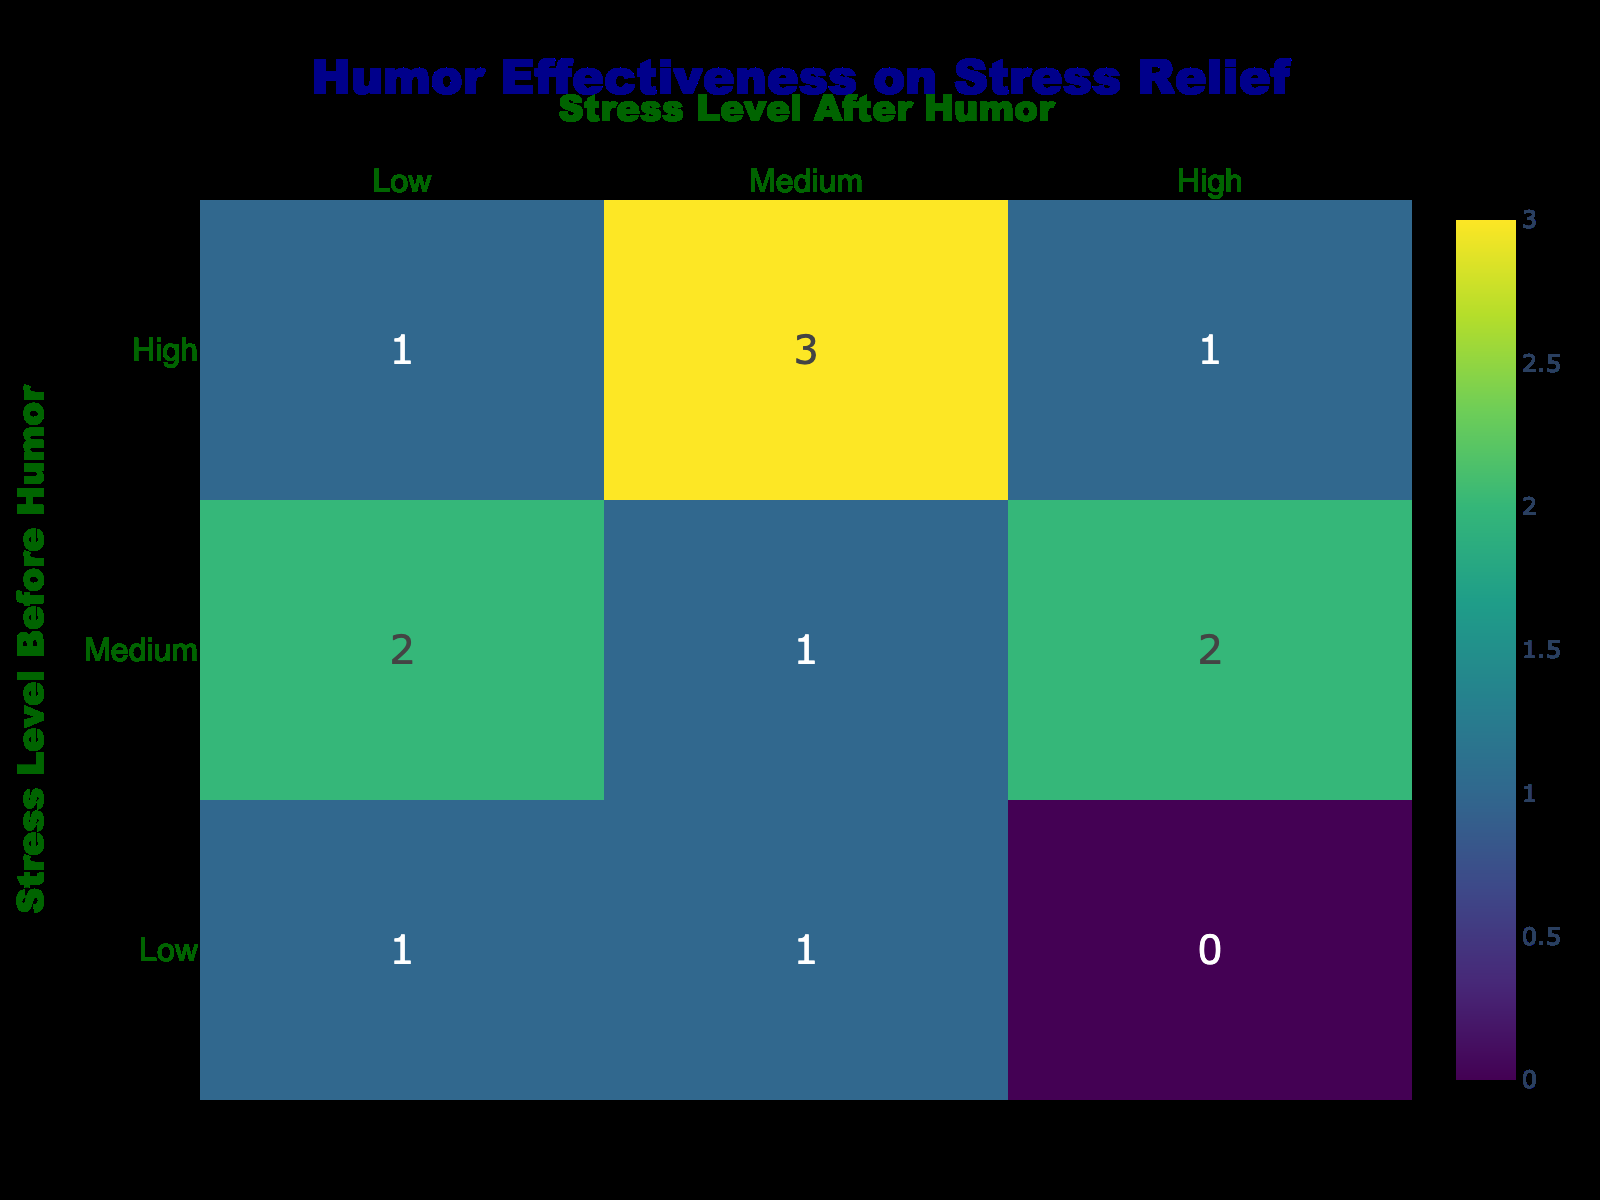What is the stress level after humor for the age group 18-24 with a high stress level before humor? Referring to the table, the only entry for the age group 18-24 with a high stress level before humor shows a stress level after humor of low.
Answer: Low How many instances show a medium stress level before humor resulted in a high stress level after humor? Looking at the table, there are no instances listed where a medium stress level before humor corresponds to a high stress level after humor. Therefore, the count is zero.
Answer: 0 What is the total number of cases where stress levels decreased after humor across all age groups? By analyzing each row where the stress level after humor is lower than the stress level before humor, we find two instances: High to Medium (25-34) and Medium to Low (45-54). Adding these gives a total of two cases where stress levels decreased after humor.
Answer: 2 Is there a case where a low stress level before humor led to a high stress level after humor? The table shows that there are no cases where a low stress level before humor resulted in a high stress level after humor. All instances demonstrate either a decrease or no change in stress level.
Answer: No Which age group has the highest total count of high stress levels before humor? Analyzing the data, the 45-54 age group has two entries with a high stress level before humor (High, High; High, Medium), which is more than any other age group. Thus, this age group has the highest count of high stress levels.
Answer: 45-54 Are there more instances of low stress levels after humor than high stress levels after humor overall? After reviewing the table, low stress levels after humor occur in three instances (one each for age groups 45-54 and 55-64, and one for 18-24). High stress levels after humor occur in four instances (two for age group 35-44 and one for 65+). Therefore, there are fewer instances of low stress levels after humor.
Answer: No How many age groups show stress levels remain unchanged after humor? Looking at the table, the age groups 18-24 (Medium), 45-54 (High), and 35-44 (Medium) have instances where the stress levels remain unchanged (Medium to Medium, High to High). Counting these gives us three age groups with unchanged stress levels.
Answer: 3 What is the proportion of cases where humor resulted in a low stress level after starting from a high stress level? To find this proportion, we identify instances starting from high stress levels (4 cases in total: 18-24, 25-34, 35-44, 45-54) that ended with a low stress level after humor (only the cases for age groups 18-24 and 25-34). This yields a proportion of 2 out of 4, resulting in a ratio of 0.5.
Answer: 0.5 